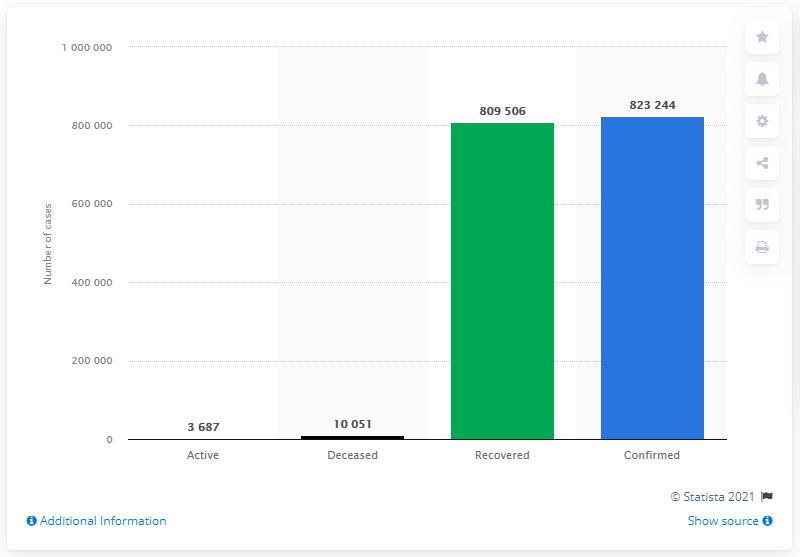Outline some significant characteristics in this image. As of today, the number of reported COVID-19 deaths worldwide is 823244. In the year 2021, there were 80,9506 cases of COVID-19 reported in the state of Gujarat. As of June 27, 2021, a total of 823,244 cases of COVID-19 had been confirmed in Gujarat. 